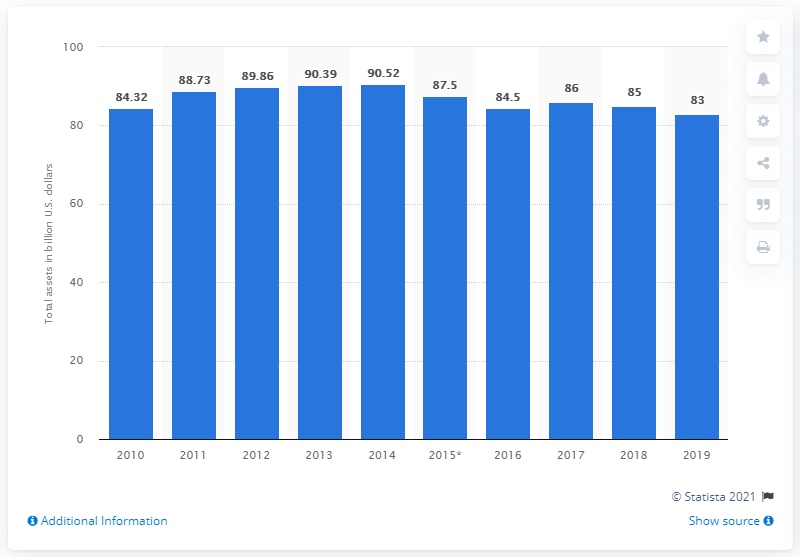Identify some key points in this picture. The total assets of SABIC in 2019 were 83... 